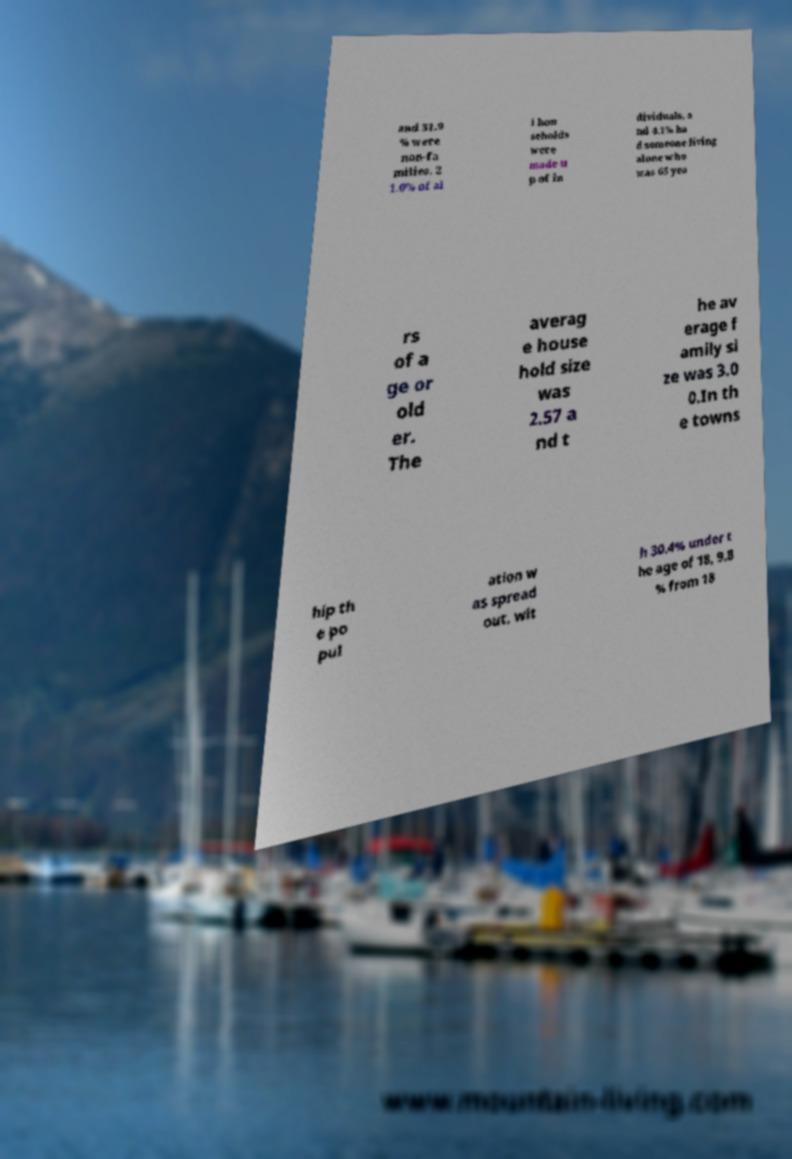There's text embedded in this image that I need extracted. Can you transcribe it verbatim? and 31.9 % were non-fa milies. 2 1.0% of al l hou seholds were made u p of in dividuals, a nd 4.1% ha d someone living alone who was 65 yea rs of a ge or old er. The averag e house hold size was 2.57 a nd t he av erage f amily si ze was 3.0 0.In th e towns hip th e po pul ation w as spread out, wit h 30.4% under t he age of 18, 9.8 % from 18 